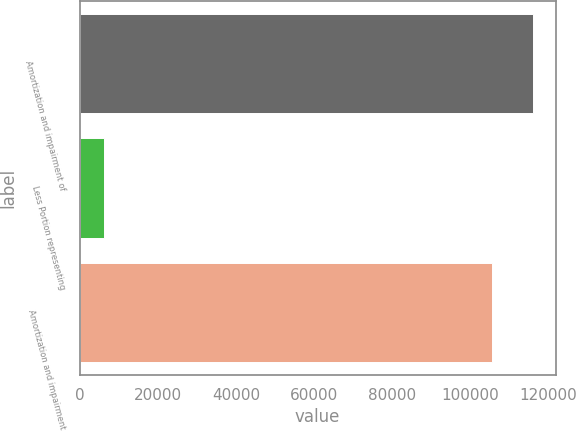<chart> <loc_0><loc_0><loc_500><loc_500><bar_chart><fcel>Amortization and impairment of<fcel>Less Portion representing<fcel>Amortization and impairment<nl><fcel>116073<fcel>6094<fcel>105521<nl></chart> 